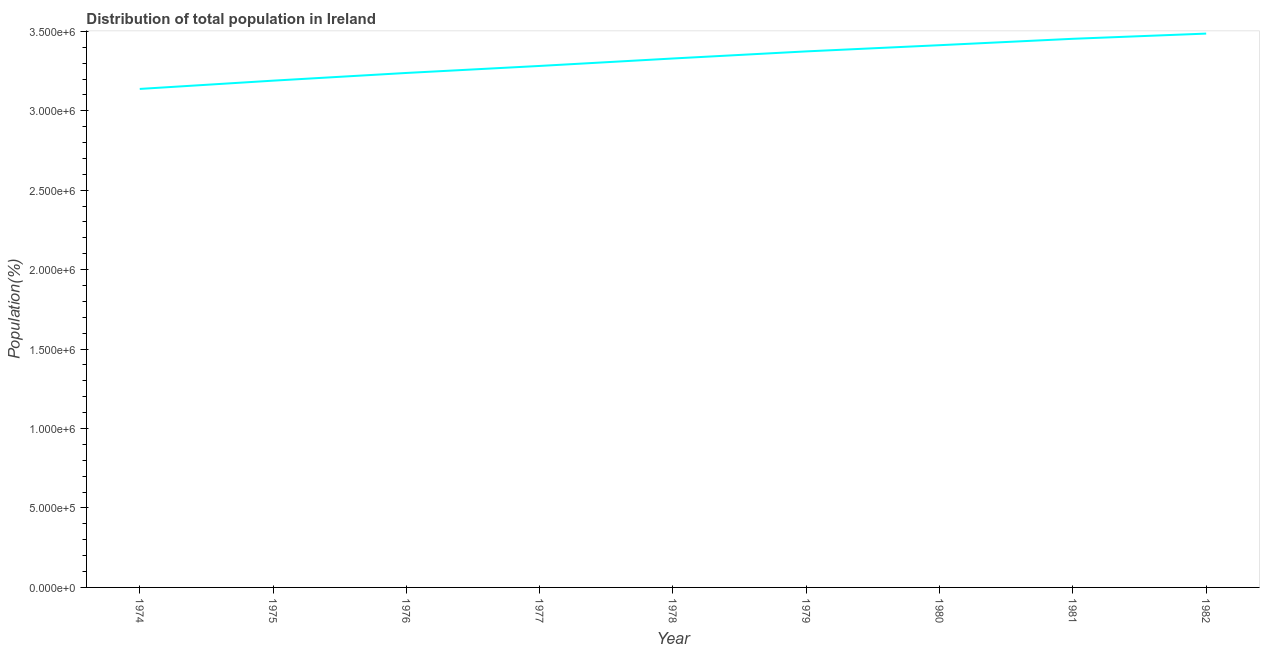What is the population in 1977?
Your answer should be very brief. 3.28e+06. Across all years, what is the maximum population?
Ensure brevity in your answer.  3.49e+06. Across all years, what is the minimum population?
Ensure brevity in your answer.  3.14e+06. In which year was the population maximum?
Keep it short and to the point. 1982. In which year was the population minimum?
Give a very brief answer. 1974. What is the sum of the population?
Offer a terse response. 2.99e+07. What is the difference between the population in 1974 and 1981?
Your answer should be compact. -3.16e+05. What is the average population per year?
Make the answer very short. 3.32e+06. What is the median population?
Your response must be concise. 3.33e+06. In how many years, is the population greater than 1600000 %?
Your response must be concise. 9. Do a majority of the years between 1975 and 1977 (inclusive) have population greater than 2100000 %?
Your answer should be very brief. Yes. What is the ratio of the population in 1976 to that in 1982?
Provide a short and direct response. 0.93. Is the population in 1978 less than that in 1979?
Your response must be concise. Yes. Is the difference between the population in 1974 and 1976 greater than the difference between any two years?
Ensure brevity in your answer.  No. What is the difference between the highest and the second highest population?
Your response must be concise. 3.28e+04. Is the sum of the population in 1975 and 1980 greater than the maximum population across all years?
Make the answer very short. Yes. What is the difference between the highest and the lowest population?
Offer a very short reply. 3.48e+05. In how many years, is the population greater than the average population taken over all years?
Provide a short and direct response. 5. Does the population monotonically increase over the years?
Provide a succinct answer. Yes. How many lines are there?
Your answer should be very brief. 1. Are the values on the major ticks of Y-axis written in scientific E-notation?
Provide a succinct answer. Yes. Does the graph contain grids?
Offer a very short reply. No. What is the title of the graph?
Give a very brief answer. Distribution of total population in Ireland . What is the label or title of the Y-axis?
Your answer should be compact. Population(%). What is the Population(%) of 1974?
Ensure brevity in your answer.  3.14e+06. What is the Population(%) in 1975?
Ensure brevity in your answer.  3.19e+06. What is the Population(%) in 1976?
Provide a short and direct response. 3.24e+06. What is the Population(%) of 1977?
Provide a short and direct response. 3.28e+06. What is the Population(%) of 1978?
Offer a very short reply. 3.33e+06. What is the Population(%) in 1979?
Make the answer very short. 3.37e+06. What is the Population(%) in 1980?
Offer a terse response. 3.41e+06. What is the Population(%) of 1981?
Your answer should be compact. 3.45e+06. What is the Population(%) of 1982?
Your answer should be very brief. 3.49e+06. What is the difference between the Population(%) in 1974 and 1975?
Make the answer very short. -5.20e+04. What is the difference between the Population(%) in 1974 and 1976?
Provide a succinct answer. -1.01e+05. What is the difference between the Population(%) in 1974 and 1977?
Offer a terse response. -1.45e+05. What is the difference between the Population(%) in 1974 and 1978?
Keep it short and to the point. -1.92e+05. What is the difference between the Population(%) in 1974 and 1979?
Your answer should be compact. -2.36e+05. What is the difference between the Population(%) in 1974 and 1980?
Your response must be concise. -2.75e+05. What is the difference between the Population(%) in 1974 and 1981?
Give a very brief answer. -3.16e+05. What is the difference between the Population(%) in 1974 and 1982?
Provide a succinct answer. -3.48e+05. What is the difference between the Population(%) in 1975 and 1976?
Provide a succinct answer. -4.85e+04. What is the difference between the Population(%) in 1975 and 1977?
Ensure brevity in your answer.  -9.26e+04. What is the difference between the Population(%) in 1975 and 1978?
Provide a succinct answer. -1.40e+05. What is the difference between the Population(%) in 1975 and 1979?
Your answer should be compact. -1.84e+05. What is the difference between the Population(%) in 1975 and 1980?
Give a very brief answer. -2.23e+05. What is the difference between the Population(%) in 1975 and 1981?
Make the answer very short. -2.63e+05. What is the difference between the Population(%) in 1975 and 1982?
Provide a succinct answer. -2.96e+05. What is the difference between the Population(%) in 1976 and 1977?
Offer a very short reply. -4.42e+04. What is the difference between the Population(%) in 1976 and 1978?
Give a very brief answer. -9.10e+04. What is the difference between the Population(%) in 1976 and 1979?
Your answer should be compact. -1.36e+05. What is the difference between the Population(%) in 1976 and 1980?
Your answer should be very brief. -1.75e+05. What is the difference between the Population(%) in 1976 and 1981?
Give a very brief answer. -2.15e+05. What is the difference between the Population(%) in 1976 and 1982?
Offer a very short reply. -2.48e+05. What is the difference between the Population(%) in 1977 and 1978?
Offer a very short reply. -4.69e+04. What is the difference between the Population(%) in 1977 and 1979?
Your response must be concise. -9.16e+04. What is the difference between the Population(%) in 1977 and 1980?
Keep it short and to the point. -1.31e+05. What is the difference between the Population(%) in 1977 and 1981?
Ensure brevity in your answer.  -1.71e+05. What is the difference between the Population(%) in 1977 and 1982?
Provide a short and direct response. -2.04e+05. What is the difference between the Population(%) in 1978 and 1979?
Make the answer very short. -4.46e+04. What is the difference between the Population(%) in 1978 and 1980?
Ensure brevity in your answer.  -8.37e+04. What is the difference between the Population(%) in 1978 and 1981?
Offer a terse response. -1.24e+05. What is the difference between the Population(%) in 1978 and 1982?
Your answer should be compact. -1.57e+05. What is the difference between the Population(%) in 1979 and 1980?
Your response must be concise. -3.90e+04. What is the difference between the Population(%) in 1979 and 1981?
Give a very brief answer. -7.92e+04. What is the difference between the Population(%) in 1979 and 1982?
Ensure brevity in your answer.  -1.12e+05. What is the difference between the Population(%) in 1980 and 1981?
Your answer should be very brief. -4.02e+04. What is the difference between the Population(%) in 1980 and 1982?
Provide a succinct answer. -7.30e+04. What is the difference between the Population(%) in 1981 and 1982?
Your answer should be compact. -3.28e+04. What is the ratio of the Population(%) in 1974 to that in 1976?
Your answer should be compact. 0.97. What is the ratio of the Population(%) in 1974 to that in 1977?
Your answer should be compact. 0.96. What is the ratio of the Population(%) in 1974 to that in 1978?
Keep it short and to the point. 0.94. What is the ratio of the Population(%) in 1974 to that in 1980?
Make the answer very short. 0.92. What is the ratio of the Population(%) in 1974 to that in 1981?
Keep it short and to the point. 0.91. What is the ratio of the Population(%) in 1975 to that in 1976?
Keep it short and to the point. 0.98. What is the ratio of the Population(%) in 1975 to that in 1977?
Your answer should be very brief. 0.97. What is the ratio of the Population(%) in 1975 to that in 1978?
Provide a short and direct response. 0.96. What is the ratio of the Population(%) in 1975 to that in 1979?
Offer a very short reply. 0.94. What is the ratio of the Population(%) in 1975 to that in 1980?
Your answer should be very brief. 0.94. What is the ratio of the Population(%) in 1975 to that in 1981?
Your answer should be compact. 0.92. What is the ratio of the Population(%) in 1975 to that in 1982?
Keep it short and to the point. 0.92. What is the ratio of the Population(%) in 1976 to that in 1979?
Ensure brevity in your answer.  0.96. What is the ratio of the Population(%) in 1976 to that in 1980?
Keep it short and to the point. 0.95. What is the ratio of the Population(%) in 1976 to that in 1981?
Give a very brief answer. 0.94. What is the ratio of the Population(%) in 1976 to that in 1982?
Your answer should be compact. 0.93. What is the ratio of the Population(%) in 1977 to that in 1978?
Provide a short and direct response. 0.99. What is the ratio of the Population(%) in 1977 to that in 1979?
Provide a succinct answer. 0.97. What is the ratio of the Population(%) in 1977 to that in 1981?
Your answer should be very brief. 0.95. What is the ratio of the Population(%) in 1977 to that in 1982?
Ensure brevity in your answer.  0.94. What is the ratio of the Population(%) in 1978 to that in 1979?
Your response must be concise. 0.99. What is the ratio of the Population(%) in 1978 to that in 1980?
Provide a short and direct response. 0.97. What is the ratio of the Population(%) in 1978 to that in 1982?
Ensure brevity in your answer.  0.95. What is the ratio of the Population(%) in 1979 to that in 1982?
Provide a succinct answer. 0.97. 